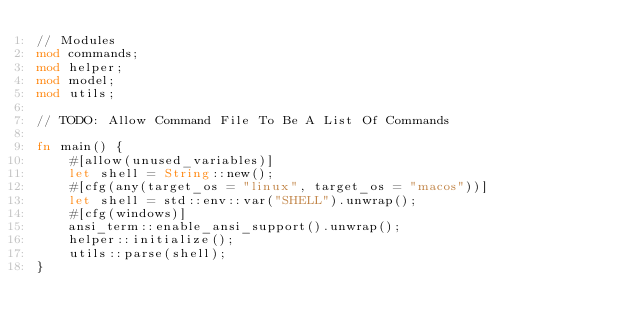<code> <loc_0><loc_0><loc_500><loc_500><_Rust_>// Modules
mod commands;
mod helper;
mod model;
mod utils;

// TODO: Allow Command File To Be A List Of Commands

fn main() {
    #[allow(unused_variables)]
    let shell = String::new();
    #[cfg(any(target_os = "linux", target_os = "macos"))]
    let shell = std::env::var("SHELL").unwrap();
    #[cfg(windows)]
    ansi_term::enable_ansi_support().unwrap();
    helper::initialize();
    utils::parse(shell);
}
</code> 